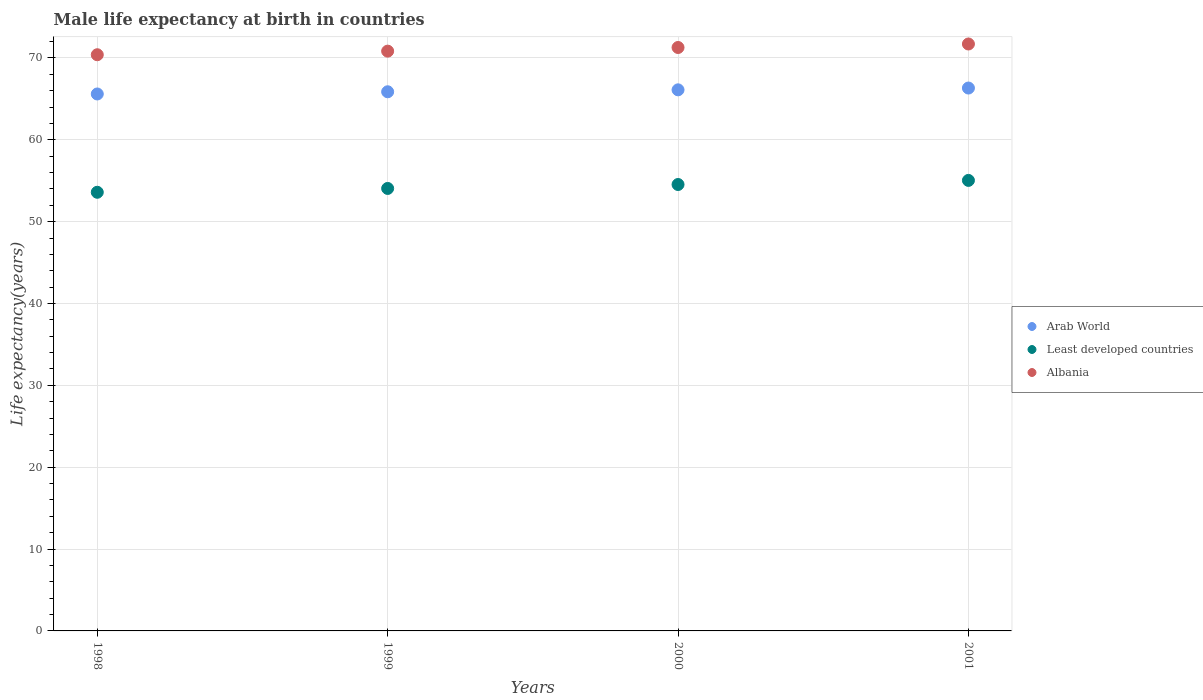How many different coloured dotlines are there?
Provide a short and direct response. 3. Is the number of dotlines equal to the number of legend labels?
Keep it short and to the point. Yes. What is the male life expectancy at birth in Least developed countries in 1998?
Provide a succinct answer. 53.59. Across all years, what is the maximum male life expectancy at birth in Albania?
Ensure brevity in your answer.  71.7. Across all years, what is the minimum male life expectancy at birth in Arab World?
Offer a terse response. 65.6. In which year was the male life expectancy at birth in Arab World maximum?
Make the answer very short. 2001. What is the total male life expectancy at birth in Albania in the graph?
Give a very brief answer. 284.2. What is the difference between the male life expectancy at birth in Arab World in 1999 and that in 2000?
Your response must be concise. -0.24. What is the difference between the male life expectancy at birth in Albania in 1998 and the male life expectancy at birth in Arab World in 2000?
Your answer should be very brief. 4.29. What is the average male life expectancy at birth in Arab World per year?
Provide a succinct answer. 65.97. In the year 2001, what is the difference between the male life expectancy at birth in Arab World and male life expectancy at birth in Least developed countries?
Offer a very short reply. 11.28. What is the ratio of the male life expectancy at birth in Least developed countries in 2000 to that in 2001?
Provide a succinct answer. 0.99. Is the male life expectancy at birth in Albania in 1998 less than that in 2001?
Offer a very short reply. Yes. What is the difference between the highest and the second highest male life expectancy at birth in Arab World?
Provide a short and direct response. 0.22. What is the difference between the highest and the lowest male life expectancy at birth in Least developed countries?
Provide a succinct answer. 1.45. In how many years, is the male life expectancy at birth in Least developed countries greater than the average male life expectancy at birth in Least developed countries taken over all years?
Offer a very short reply. 2. Does the male life expectancy at birth in Arab World monotonically increase over the years?
Your answer should be very brief. Yes. How many dotlines are there?
Keep it short and to the point. 3. How many years are there in the graph?
Provide a short and direct response. 4. Are the values on the major ticks of Y-axis written in scientific E-notation?
Keep it short and to the point. No. Does the graph contain any zero values?
Give a very brief answer. No. Does the graph contain grids?
Keep it short and to the point. Yes. What is the title of the graph?
Keep it short and to the point. Male life expectancy at birth in countries. What is the label or title of the Y-axis?
Offer a terse response. Life expectancy(years). What is the Life expectancy(years) in Arab World in 1998?
Your answer should be very brief. 65.6. What is the Life expectancy(years) in Least developed countries in 1998?
Offer a terse response. 53.59. What is the Life expectancy(years) of Albania in 1998?
Ensure brevity in your answer.  70.39. What is the Life expectancy(years) in Arab World in 1999?
Provide a succinct answer. 65.86. What is the Life expectancy(years) of Least developed countries in 1999?
Provide a short and direct response. 54.06. What is the Life expectancy(years) in Albania in 1999?
Give a very brief answer. 70.83. What is the Life expectancy(years) of Arab World in 2000?
Provide a short and direct response. 66.1. What is the Life expectancy(years) of Least developed countries in 2000?
Offer a terse response. 54.54. What is the Life expectancy(years) of Albania in 2000?
Provide a succinct answer. 71.28. What is the Life expectancy(years) in Arab World in 2001?
Provide a succinct answer. 66.32. What is the Life expectancy(years) in Least developed countries in 2001?
Keep it short and to the point. 55.04. What is the Life expectancy(years) in Albania in 2001?
Your answer should be compact. 71.7. Across all years, what is the maximum Life expectancy(years) of Arab World?
Your answer should be very brief. 66.32. Across all years, what is the maximum Life expectancy(years) in Least developed countries?
Provide a succinct answer. 55.04. Across all years, what is the maximum Life expectancy(years) in Albania?
Provide a short and direct response. 71.7. Across all years, what is the minimum Life expectancy(years) of Arab World?
Your answer should be very brief. 65.6. Across all years, what is the minimum Life expectancy(years) of Least developed countries?
Your response must be concise. 53.59. Across all years, what is the minimum Life expectancy(years) of Albania?
Keep it short and to the point. 70.39. What is the total Life expectancy(years) of Arab World in the graph?
Ensure brevity in your answer.  263.88. What is the total Life expectancy(years) of Least developed countries in the graph?
Give a very brief answer. 217.22. What is the total Life expectancy(years) in Albania in the graph?
Ensure brevity in your answer.  284.2. What is the difference between the Life expectancy(years) of Arab World in 1998 and that in 1999?
Your answer should be compact. -0.27. What is the difference between the Life expectancy(years) of Least developed countries in 1998 and that in 1999?
Provide a succinct answer. -0.47. What is the difference between the Life expectancy(years) of Albania in 1998 and that in 1999?
Your answer should be very brief. -0.44. What is the difference between the Life expectancy(years) in Arab World in 1998 and that in 2000?
Offer a very short reply. -0.51. What is the difference between the Life expectancy(years) of Least developed countries in 1998 and that in 2000?
Offer a terse response. -0.95. What is the difference between the Life expectancy(years) of Albania in 1998 and that in 2000?
Keep it short and to the point. -0.89. What is the difference between the Life expectancy(years) of Arab World in 1998 and that in 2001?
Your response must be concise. -0.73. What is the difference between the Life expectancy(years) in Least developed countries in 1998 and that in 2001?
Provide a short and direct response. -1.45. What is the difference between the Life expectancy(years) in Albania in 1998 and that in 2001?
Your answer should be compact. -1.31. What is the difference between the Life expectancy(years) in Arab World in 1999 and that in 2000?
Ensure brevity in your answer.  -0.24. What is the difference between the Life expectancy(years) in Least developed countries in 1999 and that in 2000?
Provide a succinct answer. -0.48. What is the difference between the Life expectancy(years) in Albania in 1999 and that in 2000?
Offer a very short reply. -0.45. What is the difference between the Life expectancy(years) of Arab World in 1999 and that in 2001?
Offer a very short reply. -0.46. What is the difference between the Life expectancy(years) in Least developed countries in 1999 and that in 2001?
Provide a succinct answer. -0.98. What is the difference between the Life expectancy(years) of Albania in 1999 and that in 2001?
Provide a short and direct response. -0.87. What is the difference between the Life expectancy(years) of Arab World in 2000 and that in 2001?
Provide a succinct answer. -0.22. What is the difference between the Life expectancy(years) in Least developed countries in 2000 and that in 2001?
Offer a very short reply. -0.5. What is the difference between the Life expectancy(years) in Albania in 2000 and that in 2001?
Ensure brevity in your answer.  -0.43. What is the difference between the Life expectancy(years) of Arab World in 1998 and the Life expectancy(years) of Least developed countries in 1999?
Offer a very short reply. 11.54. What is the difference between the Life expectancy(years) of Arab World in 1998 and the Life expectancy(years) of Albania in 1999?
Provide a short and direct response. -5.23. What is the difference between the Life expectancy(years) of Least developed countries in 1998 and the Life expectancy(years) of Albania in 1999?
Offer a very short reply. -17.24. What is the difference between the Life expectancy(years) of Arab World in 1998 and the Life expectancy(years) of Least developed countries in 2000?
Keep it short and to the point. 11.06. What is the difference between the Life expectancy(years) of Arab World in 1998 and the Life expectancy(years) of Albania in 2000?
Keep it short and to the point. -5.68. What is the difference between the Life expectancy(years) of Least developed countries in 1998 and the Life expectancy(years) of Albania in 2000?
Offer a terse response. -17.69. What is the difference between the Life expectancy(years) of Arab World in 1998 and the Life expectancy(years) of Least developed countries in 2001?
Your answer should be very brief. 10.56. What is the difference between the Life expectancy(years) in Arab World in 1998 and the Life expectancy(years) in Albania in 2001?
Make the answer very short. -6.11. What is the difference between the Life expectancy(years) of Least developed countries in 1998 and the Life expectancy(years) of Albania in 2001?
Offer a very short reply. -18.12. What is the difference between the Life expectancy(years) in Arab World in 1999 and the Life expectancy(years) in Least developed countries in 2000?
Offer a very short reply. 11.33. What is the difference between the Life expectancy(years) of Arab World in 1999 and the Life expectancy(years) of Albania in 2000?
Your answer should be very brief. -5.41. What is the difference between the Life expectancy(years) in Least developed countries in 1999 and the Life expectancy(years) in Albania in 2000?
Provide a succinct answer. -17.22. What is the difference between the Life expectancy(years) in Arab World in 1999 and the Life expectancy(years) in Least developed countries in 2001?
Offer a very short reply. 10.83. What is the difference between the Life expectancy(years) in Arab World in 1999 and the Life expectancy(years) in Albania in 2001?
Ensure brevity in your answer.  -5.84. What is the difference between the Life expectancy(years) in Least developed countries in 1999 and the Life expectancy(years) in Albania in 2001?
Offer a very short reply. -17.65. What is the difference between the Life expectancy(years) of Arab World in 2000 and the Life expectancy(years) of Least developed countries in 2001?
Make the answer very short. 11.06. What is the difference between the Life expectancy(years) of Arab World in 2000 and the Life expectancy(years) of Albania in 2001?
Provide a succinct answer. -5.6. What is the difference between the Life expectancy(years) of Least developed countries in 2000 and the Life expectancy(years) of Albania in 2001?
Your response must be concise. -17.17. What is the average Life expectancy(years) in Arab World per year?
Make the answer very short. 65.97. What is the average Life expectancy(years) in Least developed countries per year?
Keep it short and to the point. 54.3. What is the average Life expectancy(years) of Albania per year?
Your answer should be compact. 71.05. In the year 1998, what is the difference between the Life expectancy(years) of Arab World and Life expectancy(years) of Least developed countries?
Your answer should be very brief. 12.01. In the year 1998, what is the difference between the Life expectancy(years) of Arab World and Life expectancy(years) of Albania?
Make the answer very short. -4.79. In the year 1998, what is the difference between the Life expectancy(years) in Least developed countries and Life expectancy(years) in Albania?
Provide a succinct answer. -16.8. In the year 1999, what is the difference between the Life expectancy(years) in Arab World and Life expectancy(years) in Least developed countries?
Make the answer very short. 11.81. In the year 1999, what is the difference between the Life expectancy(years) of Arab World and Life expectancy(years) of Albania?
Your response must be concise. -4.96. In the year 1999, what is the difference between the Life expectancy(years) of Least developed countries and Life expectancy(years) of Albania?
Give a very brief answer. -16.77. In the year 2000, what is the difference between the Life expectancy(years) in Arab World and Life expectancy(years) in Least developed countries?
Keep it short and to the point. 11.56. In the year 2000, what is the difference between the Life expectancy(years) in Arab World and Life expectancy(years) in Albania?
Give a very brief answer. -5.17. In the year 2000, what is the difference between the Life expectancy(years) in Least developed countries and Life expectancy(years) in Albania?
Your answer should be very brief. -16.74. In the year 2001, what is the difference between the Life expectancy(years) in Arab World and Life expectancy(years) in Least developed countries?
Provide a short and direct response. 11.28. In the year 2001, what is the difference between the Life expectancy(years) in Arab World and Life expectancy(years) in Albania?
Your answer should be very brief. -5.38. In the year 2001, what is the difference between the Life expectancy(years) in Least developed countries and Life expectancy(years) in Albania?
Make the answer very short. -16.67. What is the ratio of the Life expectancy(years) of Arab World in 1998 to that in 1999?
Your answer should be compact. 1. What is the ratio of the Life expectancy(years) of Least developed countries in 1998 to that in 1999?
Offer a terse response. 0.99. What is the ratio of the Life expectancy(years) of Albania in 1998 to that in 1999?
Keep it short and to the point. 0.99. What is the ratio of the Life expectancy(years) of Least developed countries in 1998 to that in 2000?
Give a very brief answer. 0.98. What is the ratio of the Life expectancy(years) in Albania in 1998 to that in 2000?
Provide a succinct answer. 0.99. What is the ratio of the Life expectancy(years) in Arab World in 1998 to that in 2001?
Your response must be concise. 0.99. What is the ratio of the Life expectancy(years) in Least developed countries in 1998 to that in 2001?
Provide a succinct answer. 0.97. What is the ratio of the Life expectancy(years) of Albania in 1998 to that in 2001?
Provide a succinct answer. 0.98. What is the ratio of the Life expectancy(years) of Least developed countries in 1999 to that in 2000?
Give a very brief answer. 0.99. What is the ratio of the Life expectancy(years) of Least developed countries in 1999 to that in 2001?
Your answer should be very brief. 0.98. What is the ratio of the Life expectancy(years) of Albania in 1999 to that in 2001?
Give a very brief answer. 0.99. What is the ratio of the Life expectancy(years) in Least developed countries in 2000 to that in 2001?
Your response must be concise. 0.99. What is the ratio of the Life expectancy(years) of Albania in 2000 to that in 2001?
Give a very brief answer. 0.99. What is the difference between the highest and the second highest Life expectancy(years) of Arab World?
Your answer should be very brief. 0.22. What is the difference between the highest and the second highest Life expectancy(years) of Least developed countries?
Offer a very short reply. 0.5. What is the difference between the highest and the second highest Life expectancy(years) in Albania?
Provide a short and direct response. 0.43. What is the difference between the highest and the lowest Life expectancy(years) in Arab World?
Your response must be concise. 0.73. What is the difference between the highest and the lowest Life expectancy(years) in Least developed countries?
Your response must be concise. 1.45. What is the difference between the highest and the lowest Life expectancy(years) of Albania?
Your answer should be very brief. 1.31. 